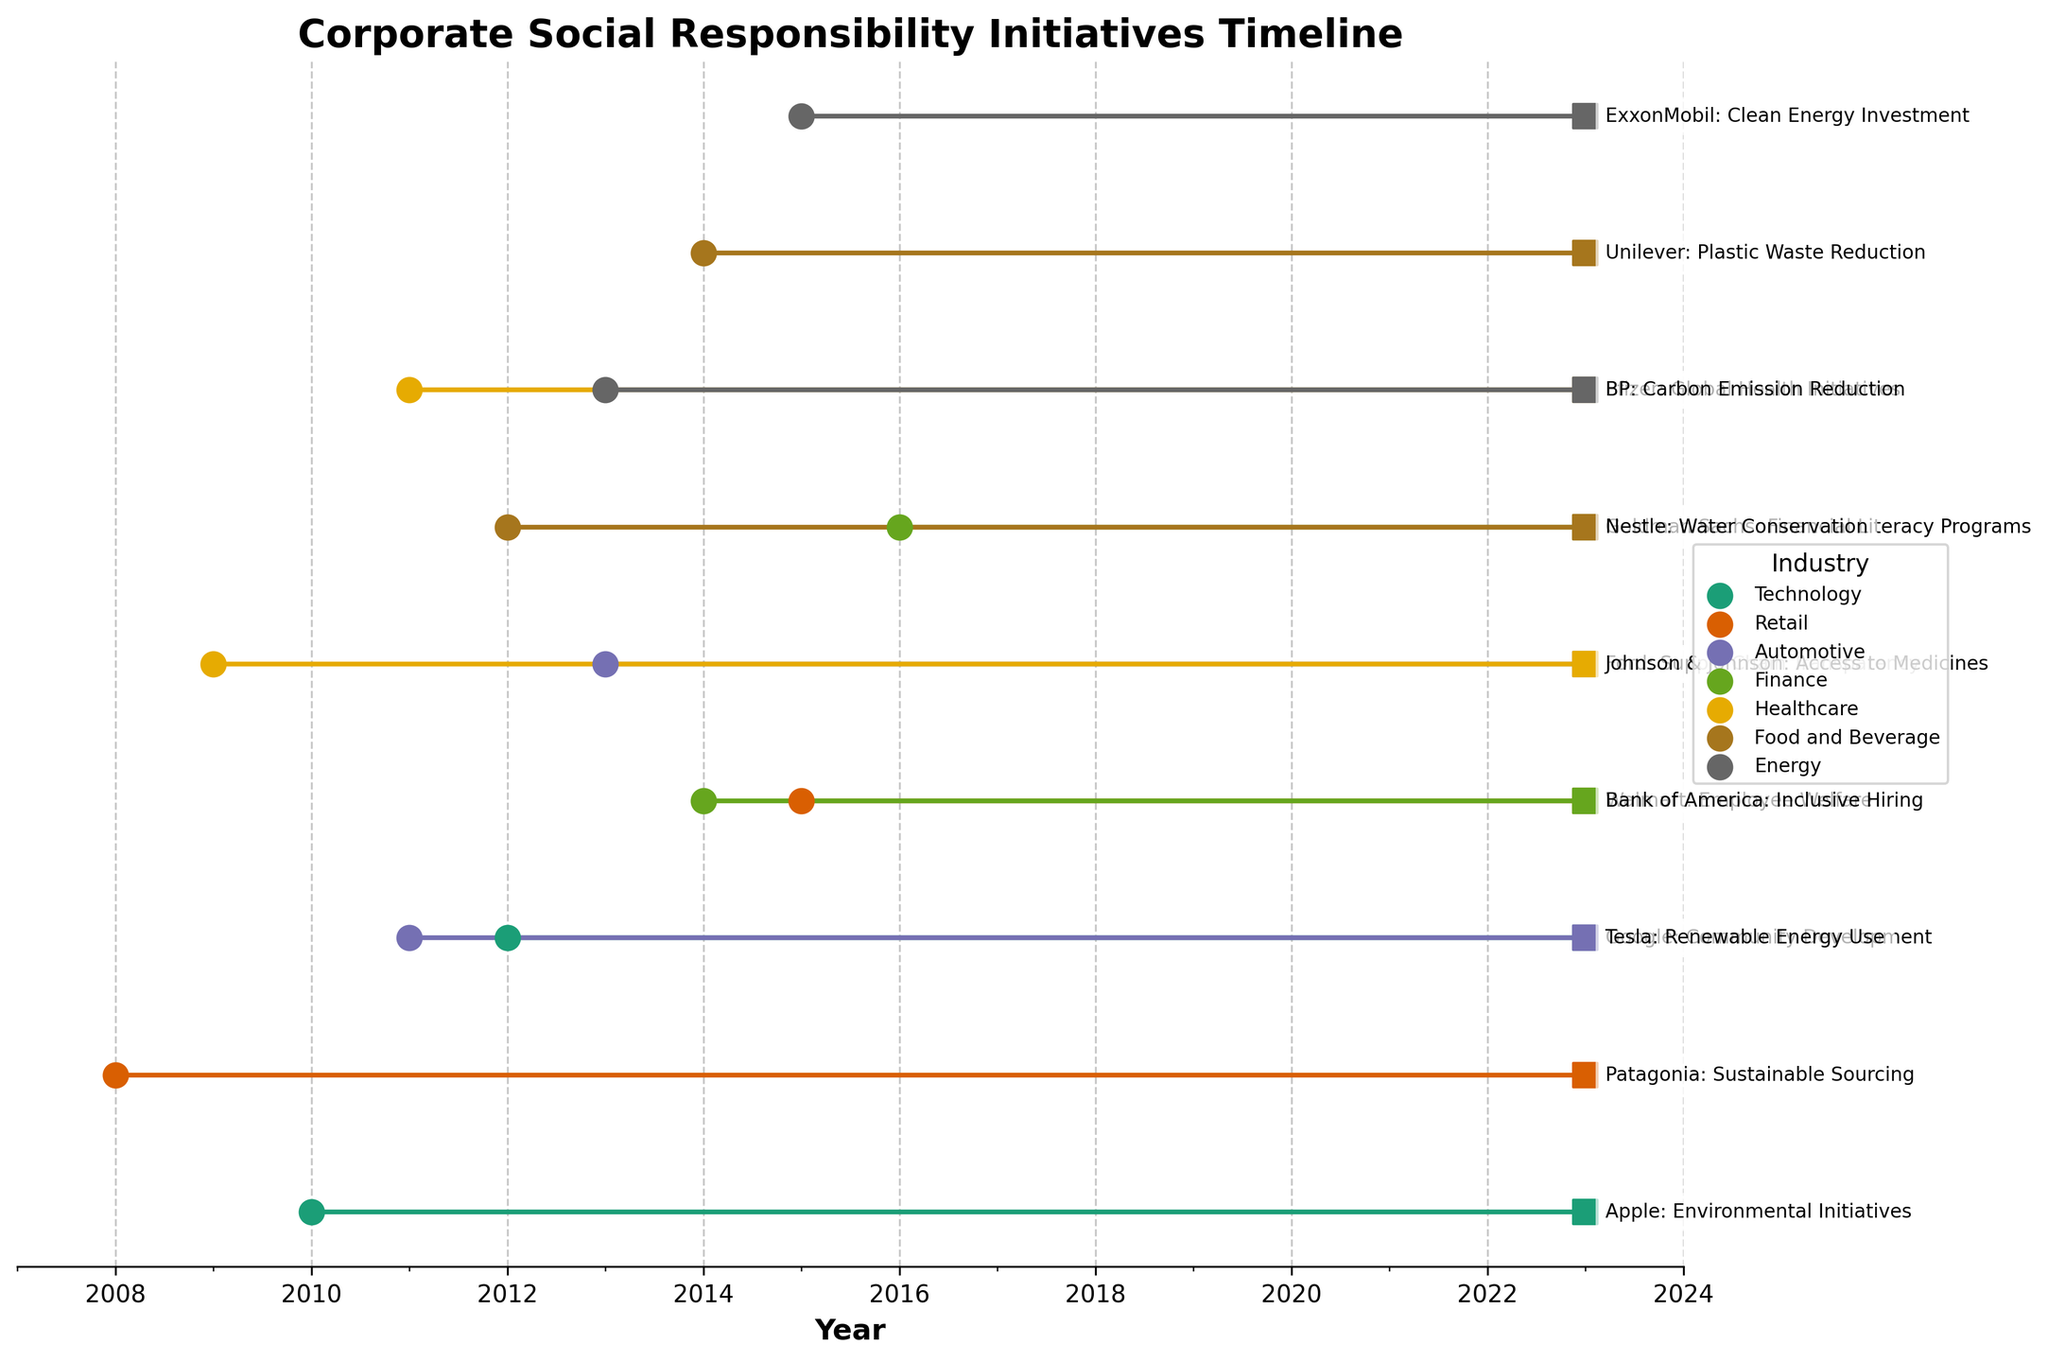what is the title of the figure? The title is usually placed at the top of the figure. It provides a description of what the figure represents. In this case, it reads "Corporate Social Responsibility Initiatives Timeline".
Answer: Corporate Social Responsibility Initiatives Timeline Which initiative started the earliest? The starting year of each initiative is indicated by a dot on the left. The initiative with the earliest starting year is Patagonia's Sustainable Sourcing, which started in 2008.
Answer: Patagonia's Sustainable Sourcing How many industries are represented in the plot? The different industries are indicated by different colors and listed in the legend on the right side of the plot. There are a total of 7 different industries displayed.
Answer: 7 What is the average duration of CSR initiatives in the healthcare industry? To find the average duration, we need to identify the healthcare initiatives and calculate the duration for each, then find the mean. Johnson & Johnson's Access to Medicines lasted from 2009 to 2023 (14 years), and Pfizer's Global Health Initiatives lasted from 2011 to 2023 (12 years). Average duration = (14+12)/2 = 13 years.
Answer: 13 years Which company in the technology industry had the longest running initiative? In the Technology industry, Apple's Environmental Initiatives lasted from 2010 to 2023 (13 years), and Google's Community Development lasted from 2012 to 2023 (11 years). So, Apple's initiative lasted longer.
Answer: Apple Compare the duration of the employee welfare initiative by Walmart and the clean energy investment initiative by ExxonMobil. Which one lasted longer? Walmart's Employee Welfare initiative lasted from 2015 to 2023 (8 years), and ExxonMobil's Clean Energy Investment lasted from 2015 to 2023 (also 8 years). Both initiatives lasted the same amount of time.
Answer: Same duration Which industry has the most number of CSR initiatives? By counting the number of dots for each industry color indicated in the legend, we see that each industry has a different count. The Retail and Healthcare industries both have the highest number of initiatives with 2 each.
Answer: Retail and Healthcare Which initiatives in the figure are related to environmental efforts? The text next to the dots on the right side of the plot indicates the name and nature of each initiative. Environmental efforts include: Apple's Environmental Initiatives, Tesla's Renewable Energy Use, BP's Carbon Emission Reduction, and Unilever's Plastic Waste Reduction.
Answer: Apple's Environmental Initiatives, Tesla's Renewable Energy Use, BP's Carbon Emission Reduction, Unilever's Plastic Waste Reduction What is the difference in duration between the shortest and longest CSR initiatives in the plot? The shortest initiative is 7 years (Goldman Sachs' Financial Literacy Programs, starting 2016 and ending 2023), and the longest is 15 years (Patagonia's Sustainable Sourcing, starting 2008 and ending 2023). The difference in duration is 15 - 7 = 8 years.
Answer: 8 years Which initiative from the automotive industry lasted until 2023 but started the latest? The initiatives in the Automotive industry are Tesla's Renewable Energy Use (2011-2023) and Ford's Supply Chain Transparency (2013-2023). Ford's Supply Chain Transparency started the latest.
Answer: Ford's Supply Chain Transparency 